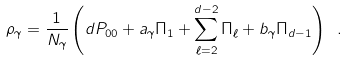<formula> <loc_0><loc_0><loc_500><loc_500>\rho _ { \gamma } = \frac { 1 } { N _ { \gamma } } \left ( d P _ { 0 0 } + a _ { \gamma } \Pi _ { 1 } + \sum _ { \ell = 2 } ^ { d - 2 } \Pi _ { \ell } + b _ { \gamma } \Pi _ { d - 1 } \right ) \ .</formula> 